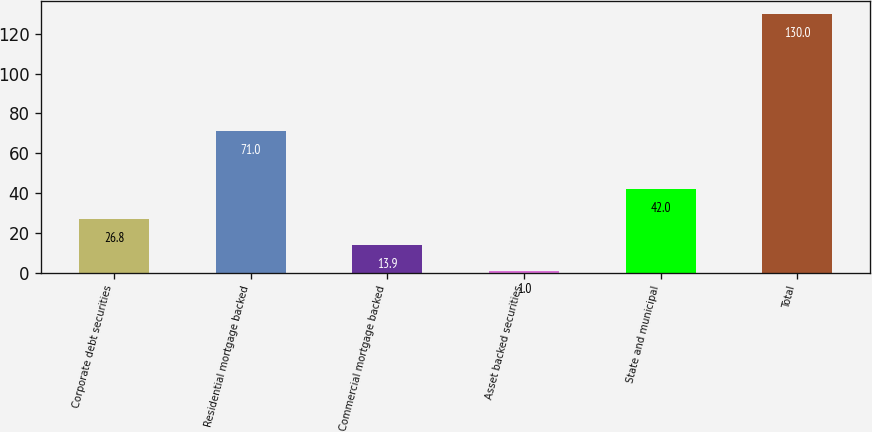<chart> <loc_0><loc_0><loc_500><loc_500><bar_chart><fcel>Corporate debt securities<fcel>Residential mortgage backed<fcel>Commercial mortgage backed<fcel>Asset backed securities<fcel>State and municipal<fcel>Total<nl><fcel>26.8<fcel>71<fcel>13.9<fcel>1<fcel>42<fcel>130<nl></chart> 